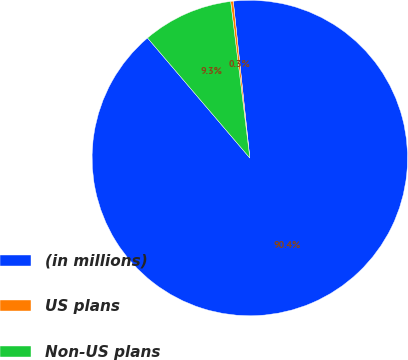Convert chart to OTSL. <chart><loc_0><loc_0><loc_500><loc_500><pie_chart><fcel>(in millions)<fcel>US plans<fcel>Non-US plans<nl><fcel>90.44%<fcel>0.27%<fcel>9.29%<nl></chart> 